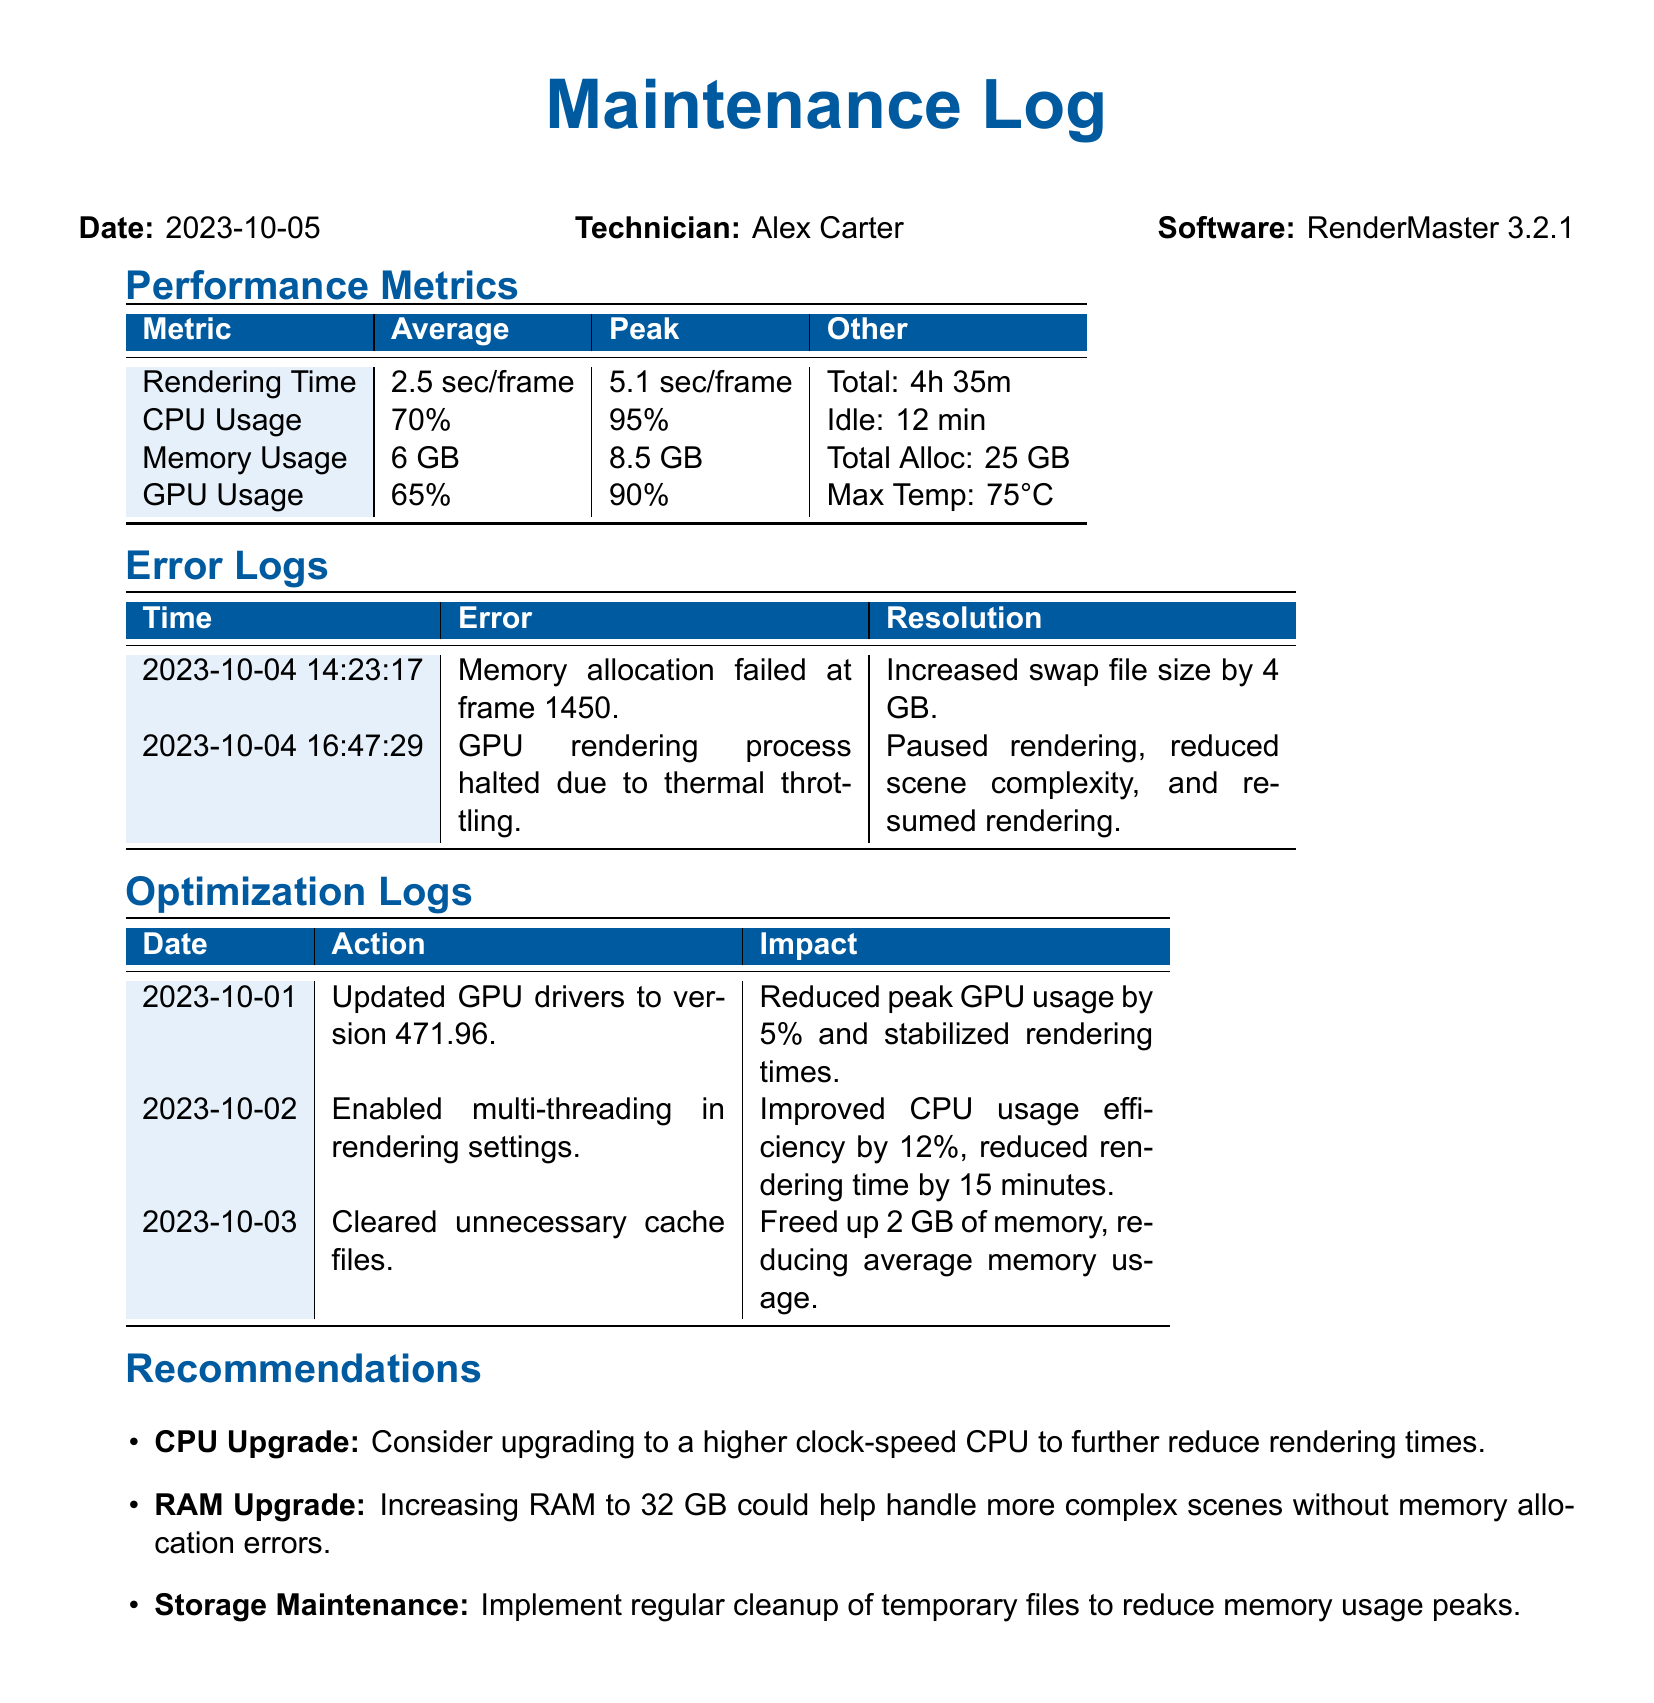What is the average rendering time? The average rendering time is specifically stated in the performance metrics section of the document.
Answer: 2.5 sec/frame What was the peak CPU usage? The peak CPU usage is listed in the performance metrics table.
Answer: 95% What action was taken on 2023-10-01? The action taken on this date is found in the optimization logs, detailing enhancements made to the system.
Answer: Updated GPU drivers to version 471.96 How much memory was freed by clearing cache files? The optimization logs specify the impact of clearing cache files on memory usage.
Answer: 2 GB What is the maximum temperature recorded for the GPU? The maximum temperature of the GPU is provided in the performance metrics section.
Answer: 75°C What is the total allocated memory? The total allocated memory is listed in the performance metrics table under memory usage.
Answer: 25 GB What was the resolution for the GPU rendering process halt? This information can be found in the error logs section regarding the GPU issue.
Answer: Paused rendering, reduced scene complexity, and resumed rendering What is a recommended action to handle more complex scenes? The recommendations section provides advice on upgrades that can improve performance.
Answer: Increasing RAM to 32 GB 